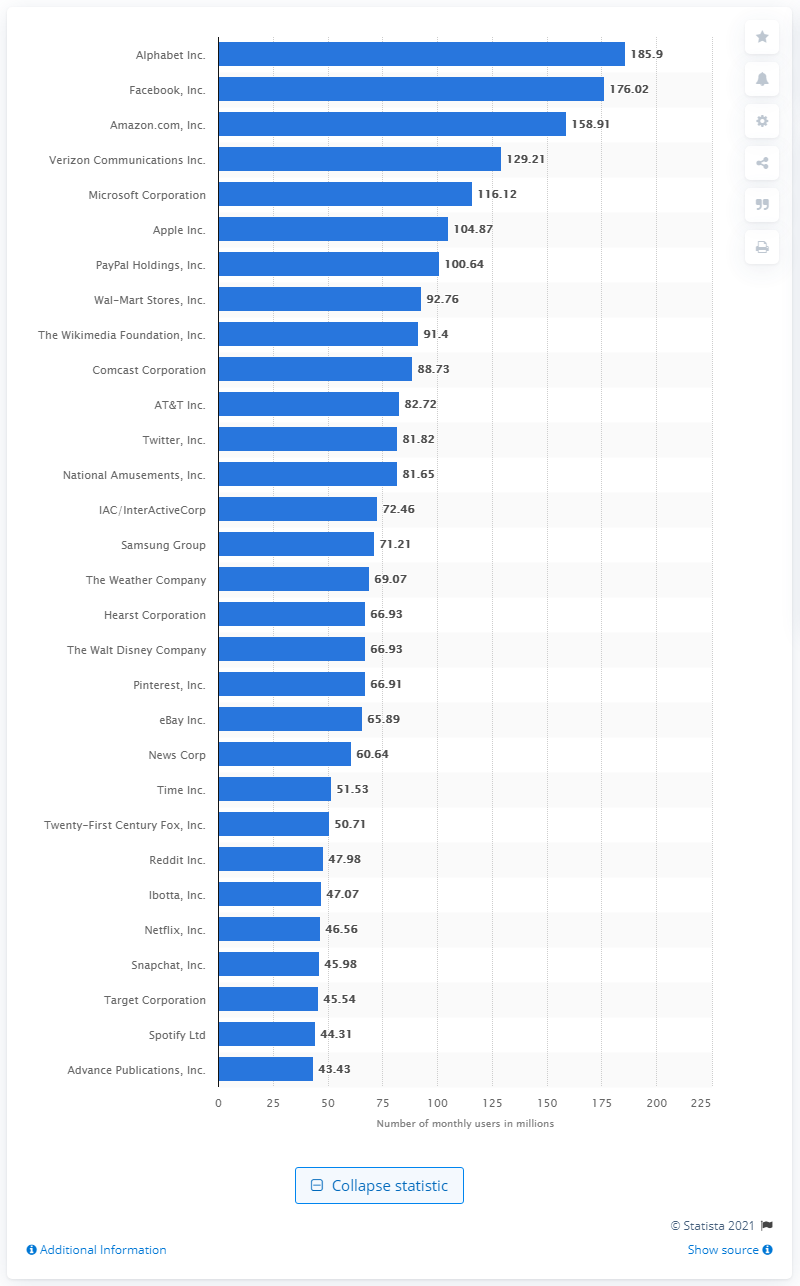List a handful of essential elements in this visual. As of the end of 2020, Alphabet's mobile app audience base was estimated to be 185.9 million users. 